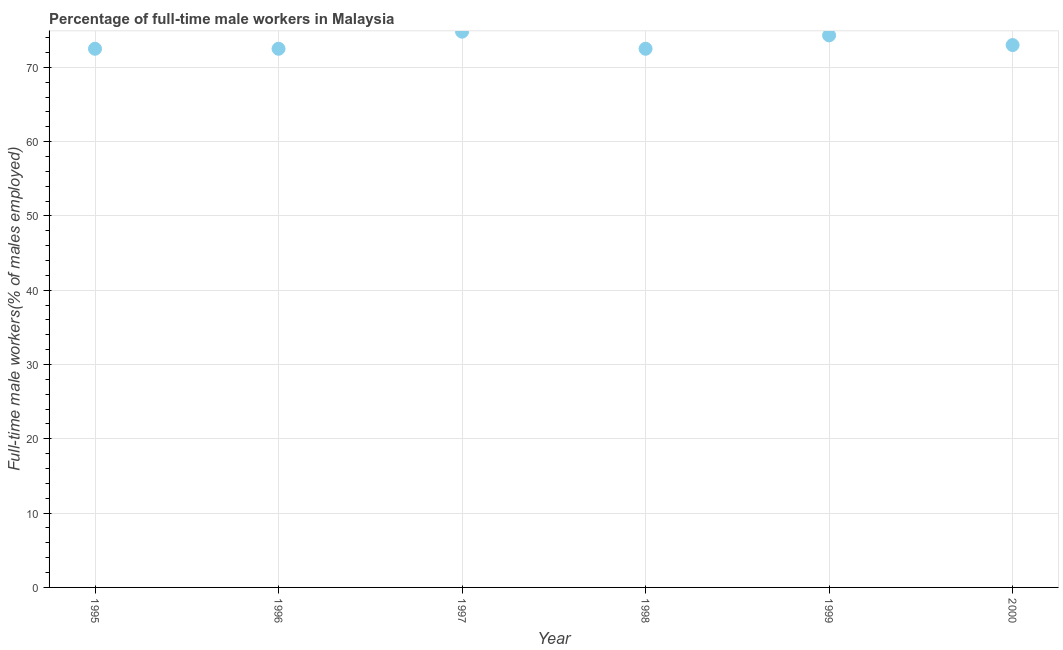What is the percentage of full-time male workers in 1995?
Ensure brevity in your answer.  72.5. Across all years, what is the maximum percentage of full-time male workers?
Offer a terse response. 74.8. Across all years, what is the minimum percentage of full-time male workers?
Provide a succinct answer. 72.5. In which year was the percentage of full-time male workers minimum?
Make the answer very short. 1995. What is the sum of the percentage of full-time male workers?
Provide a succinct answer. 439.6. What is the average percentage of full-time male workers per year?
Offer a very short reply. 73.27. What is the median percentage of full-time male workers?
Make the answer very short. 72.75. In how many years, is the percentage of full-time male workers greater than 26 %?
Make the answer very short. 6. What is the ratio of the percentage of full-time male workers in 1998 to that in 2000?
Your response must be concise. 0.99. Is the percentage of full-time male workers in 1995 less than that in 1999?
Make the answer very short. Yes. Is the difference between the percentage of full-time male workers in 1997 and 1998 greater than the difference between any two years?
Your response must be concise. Yes. What is the difference between the highest and the second highest percentage of full-time male workers?
Keep it short and to the point. 0.5. Is the sum of the percentage of full-time male workers in 1996 and 1999 greater than the maximum percentage of full-time male workers across all years?
Your answer should be very brief. Yes. What is the difference between the highest and the lowest percentage of full-time male workers?
Make the answer very short. 2.3. Are the values on the major ticks of Y-axis written in scientific E-notation?
Make the answer very short. No. Does the graph contain grids?
Your answer should be very brief. Yes. What is the title of the graph?
Offer a very short reply. Percentage of full-time male workers in Malaysia. What is the label or title of the Y-axis?
Ensure brevity in your answer.  Full-time male workers(% of males employed). What is the Full-time male workers(% of males employed) in 1995?
Offer a very short reply. 72.5. What is the Full-time male workers(% of males employed) in 1996?
Offer a terse response. 72.5. What is the Full-time male workers(% of males employed) in 1997?
Your answer should be very brief. 74.8. What is the Full-time male workers(% of males employed) in 1998?
Your answer should be very brief. 72.5. What is the Full-time male workers(% of males employed) in 1999?
Your answer should be compact. 74.3. What is the difference between the Full-time male workers(% of males employed) in 1995 and 1998?
Your answer should be compact. 0. What is the difference between the Full-time male workers(% of males employed) in 1995 and 1999?
Your answer should be very brief. -1.8. What is the difference between the Full-time male workers(% of males employed) in 1996 and 1997?
Your response must be concise. -2.3. What is the difference between the Full-time male workers(% of males employed) in 1996 and 2000?
Provide a succinct answer. -0.5. What is the difference between the Full-time male workers(% of males employed) in 1997 and 1998?
Your answer should be compact. 2.3. What is the difference between the Full-time male workers(% of males employed) in 1997 and 1999?
Make the answer very short. 0.5. What is the difference between the Full-time male workers(% of males employed) in 1998 and 1999?
Offer a terse response. -1.8. What is the difference between the Full-time male workers(% of males employed) in 1998 and 2000?
Your answer should be very brief. -0.5. What is the difference between the Full-time male workers(% of males employed) in 1999 and 2000?
Offer a terse response. 1.3. What is the ratio of the Full-time male workers(% of males employed) in 1995 to that in 1997?
Your answer should be compact. 0.97. What is the ratio of the Full-time male workers(% of males employed) in 1995 to that in 1999?
Offer a terse response. 0.98. What is the ratio of the Full-time male workers(% of males employed) in 1996 to that in 1997?
Ensure brevity in your answer.  0.97. What is the ratio of the Full-time male workers(% of males employed) in 1996 to that in 1998?
Offer a very short reply. 1. What is the ratio of the Full-time male workers(% of males employed) in 1997 to that in 1998?
Provide a succinct answer. 1.03. What is the ratio of the Full-time male workers(% of males employed) in 1997 to that in 1999?
Your answer should be compact. 1.01. What is the ratio of the Full-time male workers(% of males employed) in 1998 to that in 1999?
Your answer should be very brief. 0.98. 